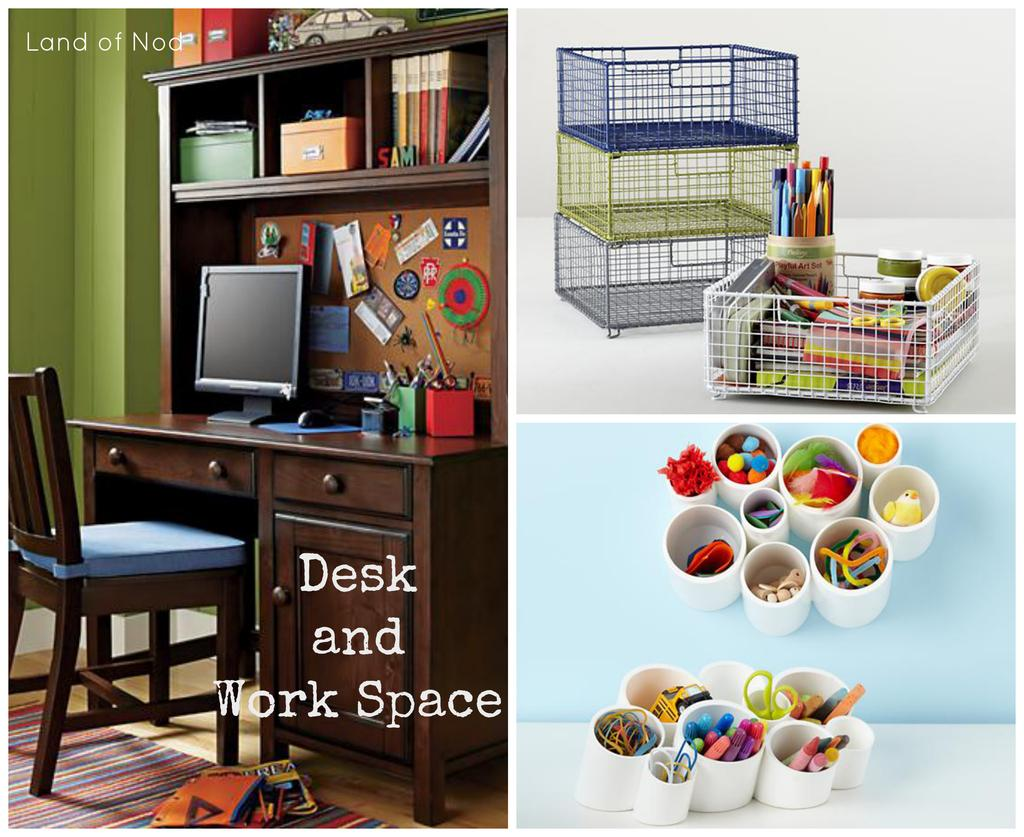Provide a one-sentence caption for the provided image. An advertisement for a desk and work space is labeled with Land of Nod at the top. 